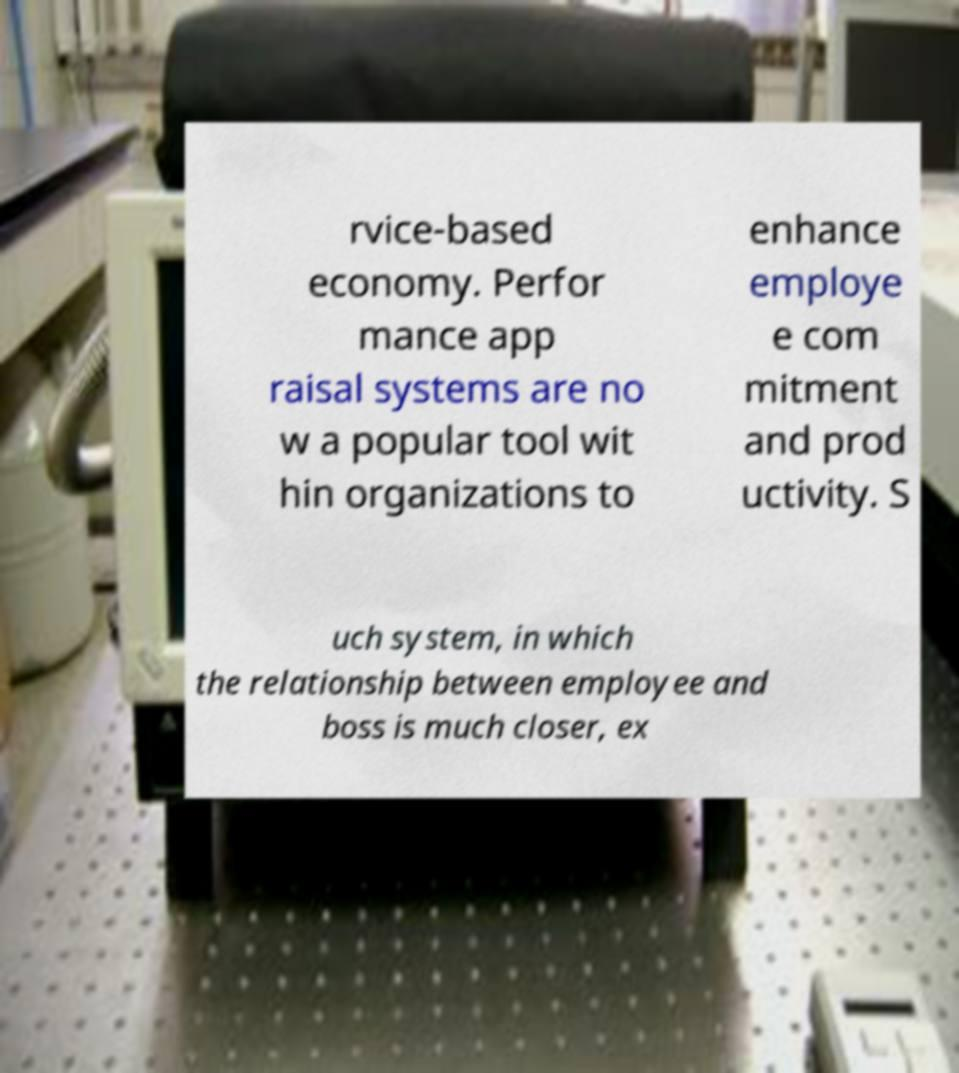Could you extract and type out the text from this image? rvice-based economy. Perfor mance app raisal systems are no w a popular tool wit hin organizations to enhance employe e com mitment and prod uctivity. S uch system, in which the relationship between employee and boss is much closer, ex 